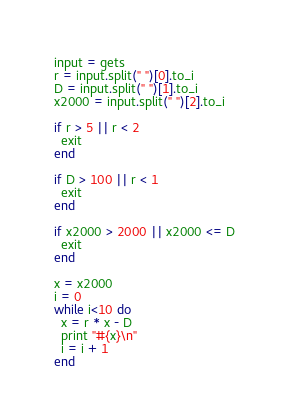Convert code to text. <code><loc_0><loc_0><loc_500><loc_500><_Ruby_>input = gets
r = input.split(" ")[0].to_i
D = input.split(" ")[1].to_i
x2000 = input.split(" ")[2].to_i

if r > 5 || r < 2
  exit
end

if D > 100 || r < 1
  exit
end

if x2000 > 2000 || x2000 <= D
  exit
end

x = x2000
i = 0
while i<10 do
  x = r * x - D
  print "#{x}\n"
  i = i + 1
end</code> 